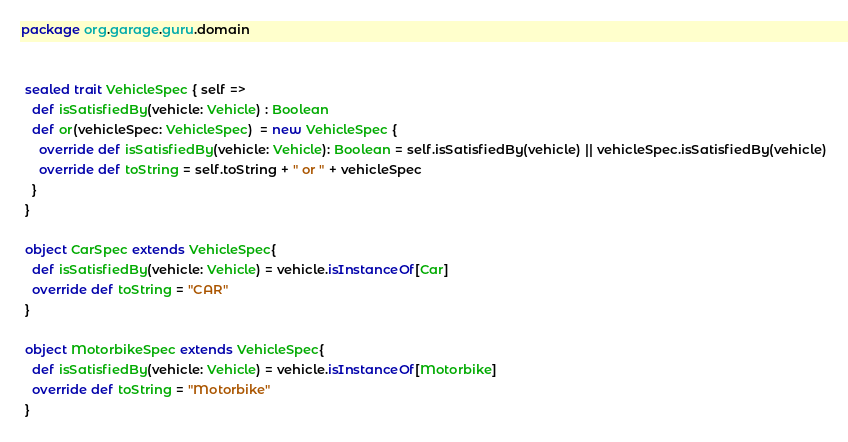Convert code to text. <code><loc_0><loc_0><loc_500><loc_500><_Scala_>package org.garage.guru.domain


 sealed trait VehicleSpec { self =>
   def isSatisfiedBy(vehicle: Vehicle) : Boolean
   def or(vehicleSpec: VehicleSpec)  = new VehicleSpec {
     override def isSatisfiedBy(vehicle: Vehicle): Boolean = self.isSatisfiedBy(vehicle) || vehicleSpec.isSatisfiedBy(vehicle)
     override def toString = self.toString + " or " + vehicleSpec
   }
 }

 object CarSpec extends VehicleSpec{
   def isSatisfiedBy(vehicle: Vehicle) = vehicle.isInstanceOf[Car]
   override def toString = "CAR"
 }

 object MotorbikeSpec extends VehicleSpec{
   def isSatisfiedBy(vehicle: Vehicle) = vehicle.isInstanceOf[Motorbike]
   override def toString = "Motorbike"
 }


</code> 